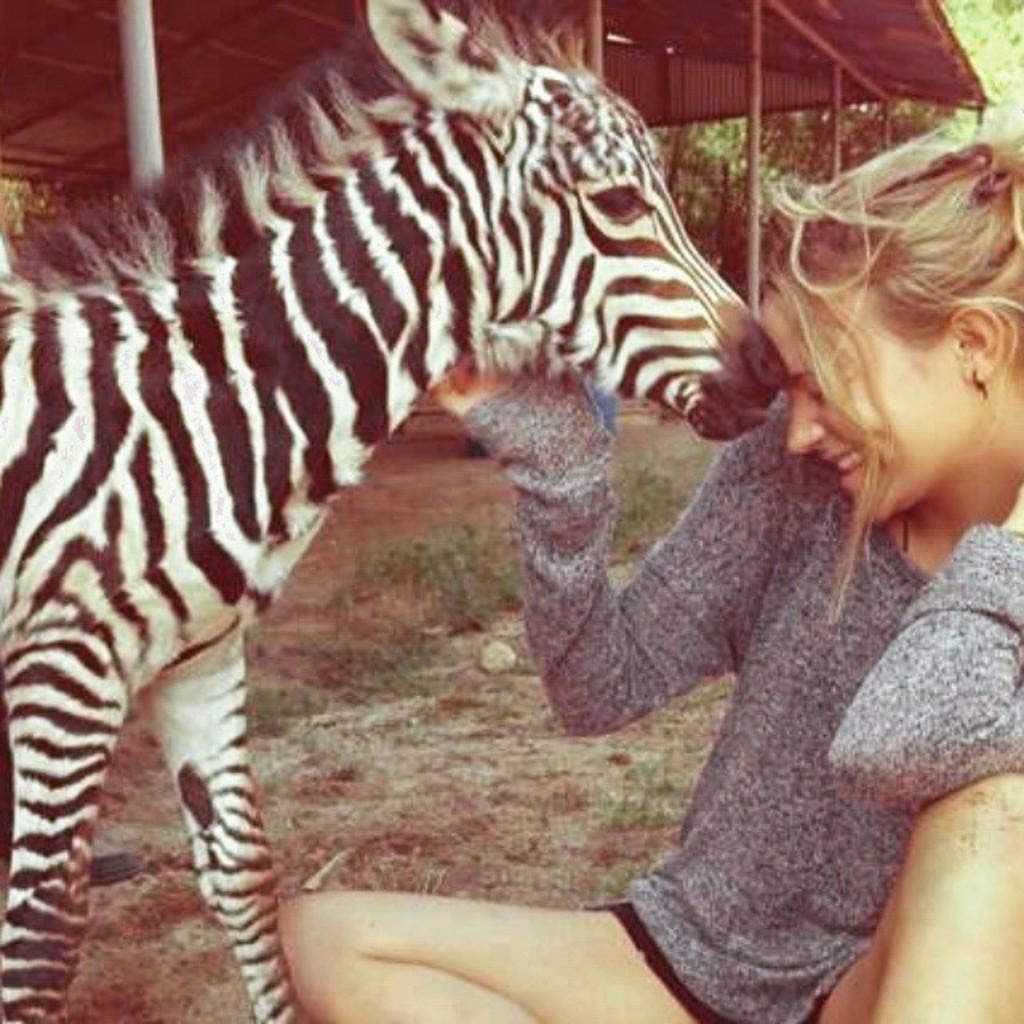What animal can be seen in the image? There is a zebra in the image. What is the person in the image doing? The person is sitting on the ground in the image. What structures can be seen in the background of the image? There is a shed and trees in the background of the image. What type of stove is present in the image? There is no stove present in the image. Can you confirm the existence of a polish in the image? There is no mention of a polish in the image, and therefore it cannot be confirmed. 